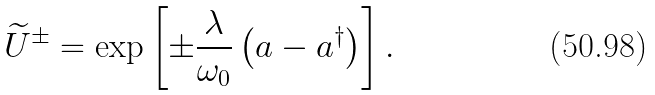Convert formula to latex. <formula><loc_0><loc_0><loc_500><loc_500>\widetilde { U } ^ { \pm } = \exp { \left [ \pm { \frac { \lambda } { \omega _ { 0 } } } \left ( a - a ^ { \dagger } \right ) \right ] } \, .</formula> 